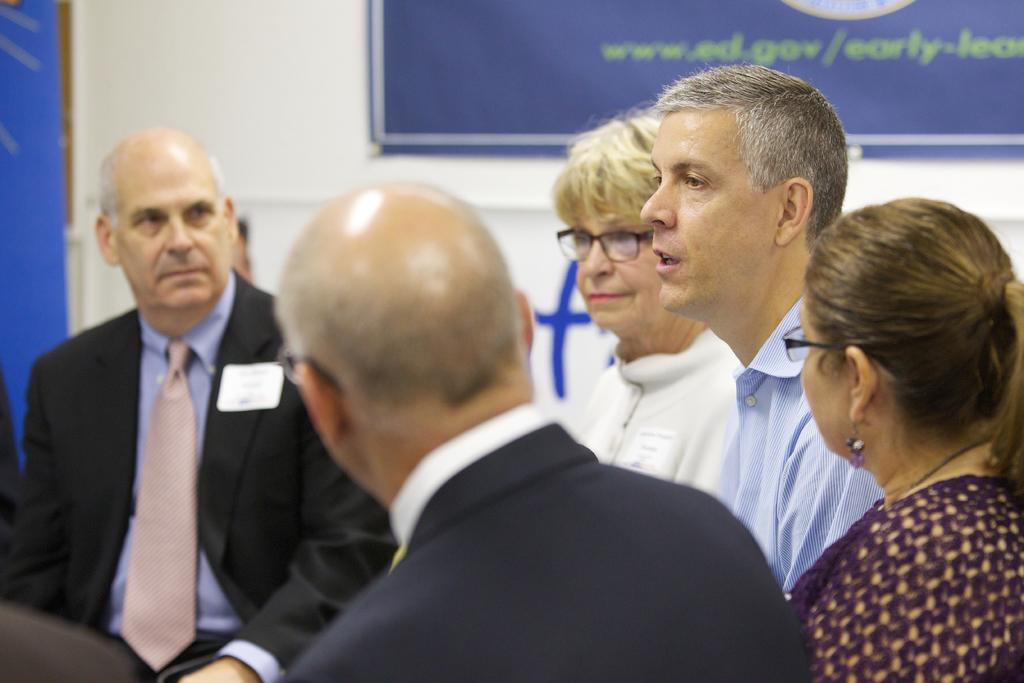How many people are present in the image? There are many people in the image. What can be seen on the wall in the background? There is a banner on the wall in the background. Is anyone speaking in the image? Yes, a person is talking in the image. What type of teeth can be seen on the banner in the image? There are no teeth visible on the banner in the image. 